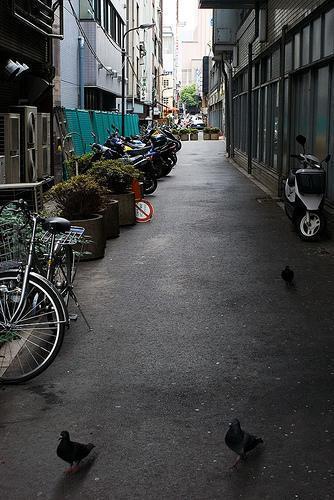How many pedal bicycles are visible in this photo?
Give a very brief answer. 2. How many pigeons are there?
Give a very brief answer. 3. How many light posts are visible?
Give a very brief answer. 3. How many mopeds are leaning against the building to the right of the image?
Give a very brief answer. 1. How many birds are on the ground?
Give a very brief answer. 3. How many potted plants are visible?
Give a very brief answer. 2. How many motorcycles are in the picture?
Give a very brief answer. 1. How many sitting people are there?
Give a very brief answer. 0. 